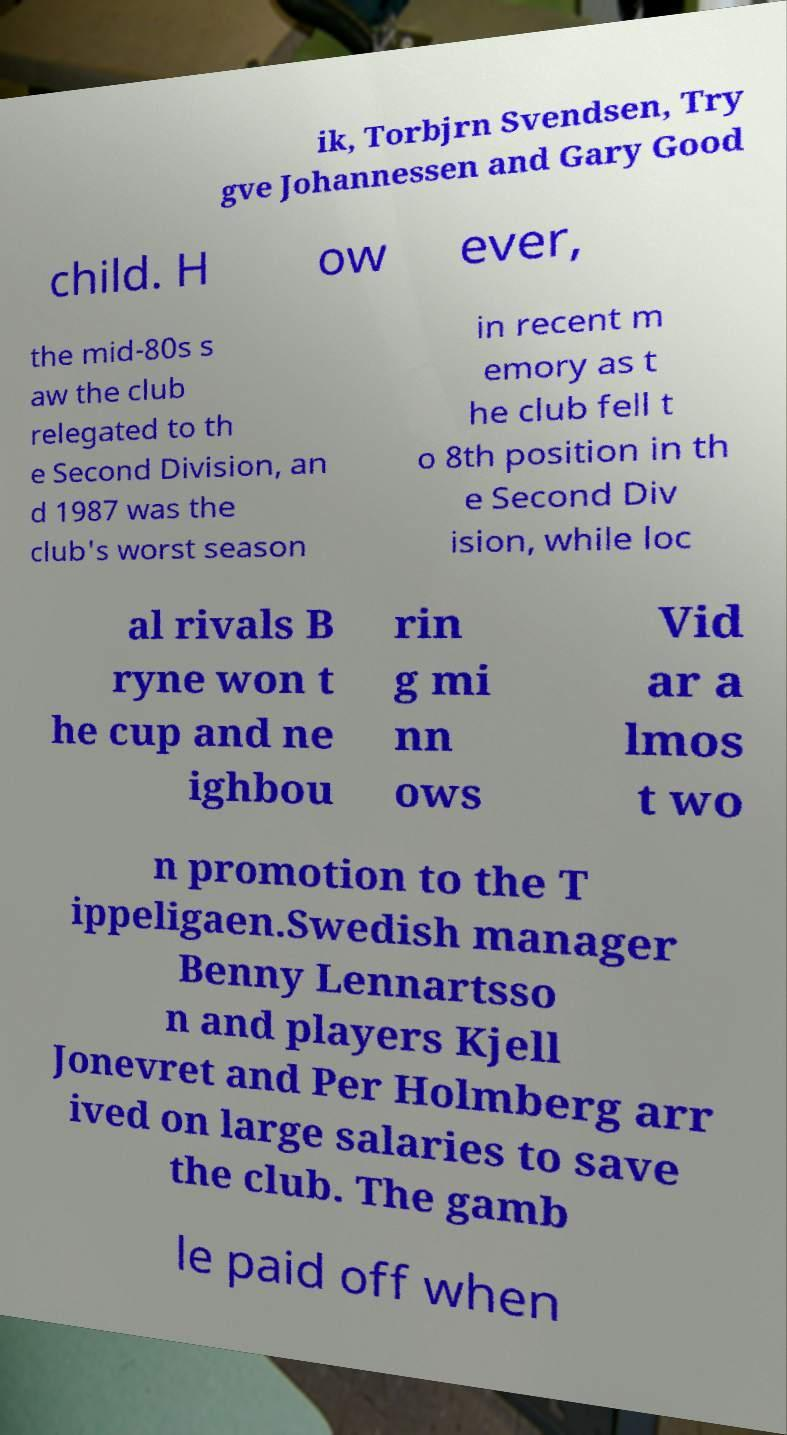Can you read and provide the text displayed in the image?This photo seems to have some interesting text. Can you extract and type it out for me? ik, Torbjrn Svendsen, Try gve Johannessen and Gary Good child. H ow ever, the mid-80s s aw the club relegated to th e Second Division, an d 1987 was the club's worst season in recent m emory as t he club fell t o 8th position in th e Second Div ision, while loc al rivals B ryne won t he cup and ne ighbou rin g mi nn ows Vid ar a lmos t wo n promotion to the T ippeligaen.Swedish manager Benny Lennartsso n and players Kjell Jonevret and Per Holmberg arr ived on large salaries to save the club. The gamb le paid off when 